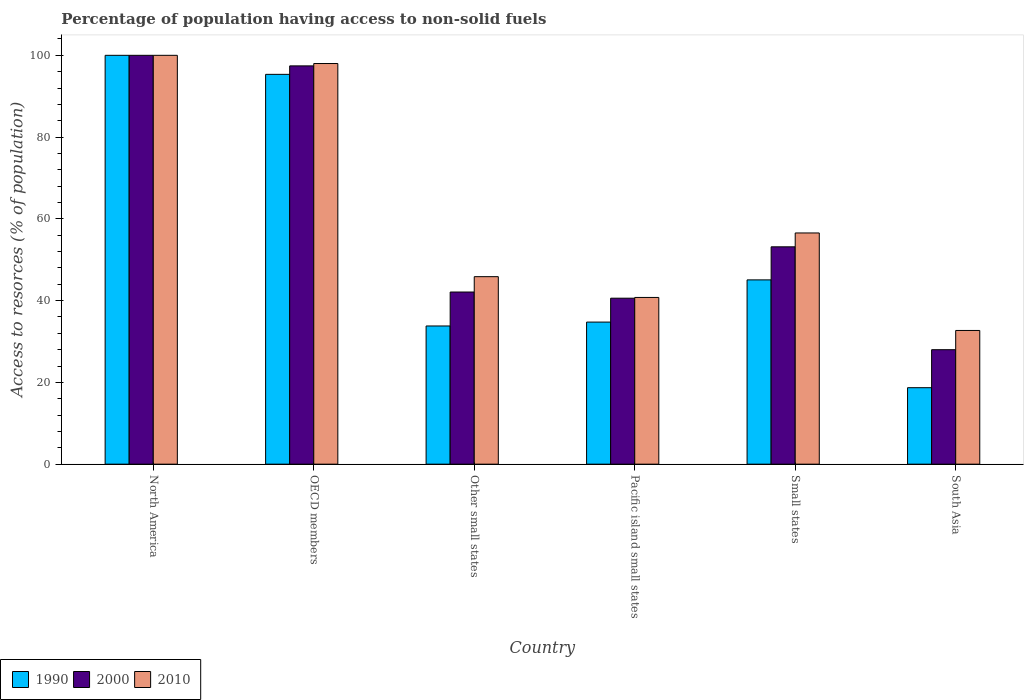Are the number of bars per tick equal to the number of legend labels?
Offer a very short reply. Yes. How many bars are there on the 5th tick from the right?
Your answer should be very brief. 3. What is the label of the 1st group of bars from the left?
Your answer should be compact. North America. What is the percentage of population having access to non-solid fuels in 2000 in OECD members?
Give a very brief answer. 97.42. Across all countries, what is the minimum percentage of population having access to non-solid fuels in 2000?
Keep it short and to the point. 28. In which country was the percentage of population having access to non-solid fuels in 1990 maximum?
Provide a succinct answer. North America. In which country was the percentage of population having access to non-solid fuels in 2000 minimum?
Provide a short and direct response. South Asia. What is the total percentage of population having access to non-solid fuels in 2010 in the graph?
Keep it short and to the point. 373.88. What is the difference between the percentage of population having access to non-solid fuels in 2010 in North America and that in Other small states?
Make the answer very short. 54.14. What is the difference between the percentage of population having access to non-solid fuels in 1990 in North America and the percentage of population having access to non-solid fuels in 2010 in Other small states?
Offer a terse response. 54.14. What is the average percentage of population having access to non-solid fuels in 2000 per country?
Offer a very short reply. 60.21. What is the difference between the percentage of population having access to non-solid fuels of/in 2010 and percentage of population having access to non-solid fuels of/in 2000 in South Asia?
Give a very brief answer. 4.71. In how many countries, is the percentage of population having access to non-solid fuels in 2010 greater than 4 %?
Offer a terse response. 6. What is the ratio of the percentage of population having access to non-solid fuels in 2000 in Other small states to that in South Asia?
Your answer should be very brief. 1.5. Is the percentage of population having access to non-solid fuels in 1990 in OECD members less than that in Small states?
Offer a very short reply. No. What is the difference between the highest and the second highest percentage of population having access to non-solid fuels in 2010?
Make the answer very short. -41.44. What is the difference between the highest and the lowest percentage of population having access to non-solid fuels in 1990?
Make the answer very short. 81.3. In how many countries, is the percentage of population having access to non-solid fuels in 2000 greater than the average percentage of population having access to non-solid fuels in 2000 taken over all countries?
Make the answer very short. 2. Is the sum of the percentage of population having access to non-solid fuels in 1990 in OECD members and Small states greater than the maximum percentage of population having access to non-solid fuels in 2010 across all countries?
Your response must be concise. Yes. What does the 2nd bar from the left in North America represents?
Provide a short and direct response. 2000. What does the 1st bar from the right in Small states represents?
Ensure brevity in your answer.  2010. Are all the bars in the graph horizontal?
Provide a short and direct response. No. Does the graph contain any zero values?
Your answer should be compact. No. What is the title of the graph?
Keep it short and to the point. Percentage of population having access to non-solid fuels. What is the label or title of the Y-axis?
Give a very brief answer. Access to resorces (% of population). What is the Access to resorces (% of population) of 1990 in North America?
Give a very brief answer. 100. What is the Access to resorces (% of population) of 1990 in OECD members?
Offer a terse response. 95.34. What is the Access to resorces (% of population) of 2000 in OECD members?
Offer a very short reply. 97.42. What is the Access to resorces (% of population) of 2010 in OECD members?
Offer a terse response. 97.99. What is the Access to resorces (% of population) of 1990 in Other small states?
Offer a terse response. 33.8. What is the Access to resorces (% of population) in 2000 in Other small states?
Give a very brief answer. 42.11. What is the Access to resorces (% of population) in 2010 in Other small states?
Your response must be concise. 45.86. What is the Access to resorces (% of population) in 1990 in Pacific island small states?
Your answer should be very brief. 34.75. What is the Access to resorces (% of population) in 2000 in Pacific island small states?
Offer a very short reply. 40.6. What is the Access to resorces (% of population) in 2010 in Pacific island small states?
Offer a very short reply. 40.78. What is the Access to resorces (% of population) of 1990 in Small states?
Make the answer very short. 45.07. What is the Access to resorces (% of population) in 2000 in Small states?
Your answer should be very brief. 53.16. What is the Access to resorces (% of population) in 2010 in Small states?
Your answer should be very brief. 56.55. What is the Access to resorces (% of population) in 1990 in South Asia?
Provide a short and direct response. 18.7. What is the Access to resorces (% of population) in 2000 in South Asia?
Your response must be concise. 28. What is the Access to resorces (% of population) of 2010 in South Asia?
Provide a short and direct response. 32.7. Across all countries, what is the maximum Access to resorces (% of population) of 1990?
Provide a short and direct response. 100. Across all countries, what is the maximum Access to resorces (% of population) in 2000?
Provide a short and direct response. 100. Across all countries, what is the maximum Access to resorces (% of population) in 2010?
Make the answer very short. 100. Across all countries, what is the minimum Access to resorces (% of population) of 1990?
Your answer should be very brief. 18.7. Across all countries, what is the minimum Access to resorces (% of population) of 2000?
Offer a terse response. 28. Across all countries, what is the minimum Access to resorces (% of population) in 2010?
Your answer should be very brief. 32.7. What is the total Access to resorces (% of population) in 1990 in the graph?
Keep it short and to the point. 327.67. What is the total Access to resorces (% of population) of 2000 in the graph?
Make the answer very short. 361.28. What is the total Access to resorces (% of population) of 2010 in the graph?
Provide a short and direct response. 373.88. What is the difference between the Access to resorces (% of population) of 1990 in North America and that in OECD members?
Give a very brief answer. 4.66. What is the difference between the Access to resorces (% of population) of 2000 in North America and that in OECD members?
Ensure brevity in your answer.  2.58. What is the difference between the Access to resorces (% of population) of 2010 in North America and that in OECD members?
Your answer should be very brief. 2.01. What is the difference between the Access to resorces (% of population) in 1990 in North America and that in Other small states?
Your answer should be compact. 66.2. What is the difference between the Access to resorces (% of population) in 2000 in North America and that in Other small states?
Ensure brevity in your answer.  57.89. What is the difference between the Access to resorces (% of population) of 2010 in North America and that in Other small states?
Provide a succinct answer. 54.14. What is the difference between the Access to resorces (% of population) in 1990 in North America and that in Pacific island small states?
Offer a terse response. 65.25. What is the difference between the Access to resorces (% of population) in 2000 in North America and that in Pacific island small states?
Your answer should be compact. 59.4. What is the difference between the Access to resorces (% of population) of 2010 in North America and that in Pacific island small states?
Offer a terse response. 59.22. What is the difference between the Access to resorces (% of population) in 1990 in North America and that in Small states?
Provide a short and direct response. 54.93. What is the difference between the Access to resorces (% of population) in 2000 in North America and that in Small states?
Offer a very short reply. 46.84. What is the difference between the Access to resorces (% of population) in 2010 in North America and that in Small states?
Provide a succinct answer. 43.45. What is the difference between the Access to resorces (% of population) of 1990 in North America and that in South Asia?
Provide a short and direct response. 81.3. What is the difference between the Access to resorces (% of population) of 2000 in North America and that in South Asia?
Provide a short and direct response. 72. What is the difference between the Access to resorces (% of population) in 2010 in North America and that in South Asia?
Your response must be concise. 67.3. What is the difference between the Access to resorces (% of population) in 1990 in OECD members and that in Other small states?
Keep it short and to the point. 61.54. What is the difference between the Access to resorces (% of population) of 2000 in OECD members and that in Other small states?
Give a very brief answer. 55.31. What is the difference between the Access to resorces (% of population) in 2010 in OECD members and that in Other small states?
Provide a succinct answer. 52.13. What is the difference between the Access to resorces (% of population) in 1990 in OECD members and that in Pacific island small states?
Your response must be concise. 60.59. What is the difference between the Access to resorces (% of population) in 2000 in OECD members and that in Pacific island small states?
Offer a terse response. 56.82. What is the difference between the Access to resorces (% of population) in 2010 in OECD members and that in Pacific island small states?
Your response must be concise. 57.22. What is the difference between the Access to resorces (% of population) of 1990 in OECD members and that in Small states?
Your answer should be compact. 50.27. What is the difference between the Access to resorces (% of population) of 2000 in OECD members and that in Small states?
Give a very brief answer. 44.26. What is the difference between the Access to resorces (% of population) of 2010 in OECD members and that in Small states?
Your answer should be very brief. 41.44. What is the difference between the Access to resorces (% of population) in 1990 in OECD members and that in South Asia?
Your answer should be very brief. 76.64. What is the difference between the Access to resorces (% of population) in 2000 in OECD members and that in South Asia?
Provide a short and direct response. 69.42. What is the difference between the Access to resorces (% of population) of 2010 in OECD members and that in South Asia?
Your answer should be very brief. 65.29. What is the difference between the Access to resorces (% of population) in 1990 in Other small states and that in Pacific island small states?
Make the answer very short. -0.95. What is the difference between the Access to resorces (% of population) in 2000 in Other small states and that in Pacific island small states?
Provide a succinct answer. 1.51. What is the difference between the Access to resorces (% of population) of 2010 in Other small states and that in Pacific island small states?
Provide a short and direct response. 5.08. What is the difference between the Access to resorces (% of population) in 1990 in Other small states and that in Small states?
Your answer should be compact. -11.27. What is the difference between the Access to resorces (% of population) of 2000 in Other small states and that in Small states?
Make the answer very short. -11.06. What is the difference between the Access to resorces (% of population) of 2010 in Other small states and that in Small states?
Offer a very short reply. -10.69. What is the difference between the Access to resorces (% of population) of 1990 in Other small states and that in South Asia?
Your answer should be compact. 15.1. What is the difference between the Access to resorces (% of population) in 2000 in Other small states and that in South Asia?
Ensure brevity in your answer.  14.11. What is the difference between the Access to resorces (% of population) of 2010 in Other small states and that in South Asia?
Your answer should be compact. 13.16. What is the difference between the Access to resorces (% of population) in 1990 in Pacific island small states and that in Small states?
Offer a very short reply. -10.32. What is the difference between the Access to resorces (% of population) in 2000 in Pacific island small states and that in Small states?
Keep it short and to the point. -12.57. What is the difference between the Access to resorces (% of population) of 2010 in Pacific island small states and that in Small states?
Offer a terse response. -15.77. What is the difference between the Access to resorces (% of population) of 1990 in Pacific island small states and that in South Asia?
Make the answer very short. 16.05. What is the difference between the Access to resorces (% of population) of 2000 in Pacific island small states and that in South Asia?
Ensure brevity in your answer.  12.6. What is the difference between the Access to resorces (% of population) of 2010 in Pacific island small states and that in South Asia?
Keep it short and to the point. 8.07. What is the difference between the Access to resorces (% of population) in 1990 in Small states and that in South Asia?
Offer a very short reply. 26.37. What is the difference between the Access to resorces (% of population) of 2000 in Small states and that in South Asia?
Offer a terse response. 25.16. What is the difference between the Access to resorces (% of population) in 2010 in Small states and that in South Asia?
Give a very brief answer. 23.85. What is the difference between the Access to resorces (% of population) of 1990 in North America and the Access to resorces (% of population) of 2000 in OECD members?
Ensure brevity in your answer.  2.58. What is the difference between the Access to resorces (% of population) in 1990 in North America and the Access to resorces (% of population) in 2010 in OECD members?
Provide a short and direct response. 2.01. What is the difference between the Access to resorces (% of population) in 2000 in North America and the Access to resorces (% of population) in 2010 in OECD members?
Offer a terse response. 2.01. What is the difference between the Access to resorces (% of population) in 1990 in North America and the Access to resorces (% of population) in 2000 in Other small states?
Provide a succinct answer. 57.89. What is the difference between the Access to resorces (% of population) of 1990 in North America and the Access to resorces (% of population) of 2010 in Other small states?
Your answer should be compact. 54.14. What is the difference between the Access to resorces (% of population) in 2000 in North America and the Access to resorces (% of population) in 2010 in Other small states?
Your answer should be very brief. 54.14. What is the difference between the Access to resorces (% of population) of 1990 in North America and the Access to resorces (% of population) of 2000 in Pacific island small states?
Make the answer very short. 59.4. What is the difference between the Access to resorces (% of population) in 1990 in North America and the Access to resorces (% of population) in 2010 in Pacific island small states?
Make the answer very short. 59.22. What is the difference between the Access to resorces (% of population) in 2000 in North America and the Access to resorces (% of population) in 2010 in Pacific island small states?
Keep it short and to the point. 59.22. What is the difference between the Access to resorces (% of population) of 1990 in North America and the Access to resorces (% of population) of 2000 in Small states?
Your answer should be very brief. 46.84. What is the difference between the Access to resorces (% of population) of 1990 in North America and the Access to resorces (% of population) of 2010 in Small states?
Ensure brevity in your answer.  43.45. What is the difference between the Access to resorces (% of population) in 2000 in North America and the Access to resorces (% of population) in 2010 in Small states?
Your response must be concise. 43.45. What is the difference between the Access to resorces (% of population) of 1990 in North America and the Access to resorces (% of population) of 2000 in South Asia?
Your answer should be very brief. 72. What is the difference between the Access to resorces (% of population) in 1990 in North America and the Access to resorces (% of population) in 2010 in South Asia?
Ensure brevity in your answer.  67.3. What is the difference between the Access to resorces (% of population) in 2000 in North America and the Access to resorces (% of population) in 2010 in South Asia?
Your answer should be compact. 67.3. What is the difference between the Access to resorces (% of population) in 1990 in OECD members and the Access to resorces (% of population) in 2000 in Other small states?
Provide a short and direct response. 53.24. What is the difference between the Access to resorces (% of population) of 1990 in OECD members and the Access to resorces (% of population) of 2010 in Other small states?
Your answer should be very brief. 49.48. What is the difference between the Access to resorces (% of population) of 2000 in OECD members and the Access to resorces (% of population) of 2010 in Other small states?
Provide a succinct answer. 51.56. What is the difference between the Access to resorces (% of population) in 1990 in OECD members and the Access to resorces (% of population) in 2000 in Pacific island small states?
Your response must be concise. 54.75. What is the difference between the Access to resorces (% of population) in 1990 in OECD members and the Access to resorces (% of population) in 2010 in Pacific island small states?
Give a very brief answer. 54.57. What is the difference between the Access to resorces (% of population) in 2000 in OECD members and the Access to resorces (% of population) in 2010 in Pacific island small states?
Make the answer very short. 56.64. What is the difference between the Access to resorces (% of population) of 1990 in OECD members and the Access to resorces (% of population) of 2000 in Small states?
Provide a succinct answer. 42.18. What is the difference between the Access to resorces (% of population) in 1990 in OECD members and the Access to resorces (% of population) in 2010 in Small states?
Make the answer very short. 38.79. What is the difference between the Access to resorces (% of population) of 2000 in OECD members and the Access to resorces (% of population) of 2010 in Small states?
Your answer should be compact. 40.87. What is the difference between the Access to resorces (% of population) in 1990 in OECD members and the Access to resorces (% of population) in 2000 in South Asia?
Provide a short and direct response. 67.35. What is the difference between the Access to resorces (% of population) of 1990 in OECD members and the Access to resorces (% of population) of 2010 in South Asia?
Your answer should be compact. 62.64. What is the difference between the Access to resorces (% of population) in 2000 in OECD members and the Access to resorces (% of population) in 2010 in South Asia?
Your answer should be compact. 64.71. What is the difference between the Access to resorces (% of population) in 1990 in Other small states and the Access to resorces (% of population) in 2000 in Pacific island small states?
Offer a very short reply. -6.8. What is the difference between the Access to resorces (% of population) of 1990 in Other small states and the Access to resorces (% of population) of 2010 in Pacific island small states?
Your response must be concise. -6.98. What is the difference between the Access to resorces (% of population) of 2000 in Other small states and the Access to resorces (% of population) of 2010 in Pacific island small states?
Your response must be concise. 1.33. What is the difference between the Access to resorces (% of population) in 1990 in Other small states and the Access to resorces (% of population) in 2000 in Small states?
Your answer should be very brief. -19.36. What is the difference between the Access to resorces (% of population) of 1990 in Other small states and the Access to resorces (% of population) of 2010 in Small states?
Provide a short and direct response. -22.75. What is the difference between the Access to resorces (% of population) of 2000 in Other small states and the Access to resorces (% of population) of 2010 in Small states?
Provide a succinct answer. -14.44. What is the difference between the Access to resorces (% of population) in 1990 in Other small states and the Access to resorces (% of population) in 2000 in South Asia?
Your response must be concise. 5.8. What is the difference between the Access to resorces (% of population) in 1990 in Other small states and the Access to resorces (% of population) in 2010 in South Asia?
Provide a succinct answer. 1.1. What is the difference between the Access to resorces (% of population) in 2000 in Other small states and the Access to resorces (% of population) in 2010 in South Asia?
Your response must be concise. 9.4. What is the difference between the Access to resorces (% of population) of 1990 in Pacific island small states and the Access to resorces (% of population) of 2000 in Small states?
Ensure brevity in your answer.  -18.41. What is the difference between the Access to resorces (% of population) in 1990 in Pacific island small states and the Access to resorces (% of population) in 2010 in Small states?
Make the answer very short. -21.8. What is the difference between the Access to resorces (% of population) of 2000 in Pacific island small states and the Access to resorces (% of population) of 2010 in Small states?
Your answer should be compact. -15.95. What is the difference between the Access to resorces (% of population) in 1990 in Pacific island small states and the Access to resorces (% of population) in 2000 in South Asia?
Offer a very short reply. 6.75. What is the difference between the Access to resorces (% of population) in 1990 in Pacific island small states and the Access to resorces (% of population) in 2010 in South Asia?
Provide a short and direct response. 2.05. What is the difference between the Access to resorces (% of population) in 2000 in Pacific island small states and the Access to resorces (% of population) in 2010 in South Asia?
Make the answer very short. 7.89. What is the difference between the Access to resorces (% of population) in 1990 in Small states and the Access to resorces (% of population) in 2000 in South Asia?
Ensure brevity in your answer.  17.08. What is the difference between the Access to resorces (% of population) in 1990 in Small states and the Access to resorces (% of population) in 2010 in South Asia?
Provide a succinct answer. 12.37. What is the difference between the Access to resorces (% of population) in 2000 in Small states and the Access to resorces (% of population) in 2010 in South Asia?
Keep it short and to the point. 20.46. What is the average Access to resorces (% of population) in 1990 per country?
Give a very brief answer. 54.61. What is the average Access to resorces (% of population) in 2000 per country?
Your answer should be compact. 60.21. What is the average Access to resorces (% of population) of 2010 per country?
Your response must be concise. 62.31. What is the difference between the Access to resorces (% of population) in 1990 and Access to resorces (% of population) in 2000 in North America?
Ensure brevity in your answer.  0. What is the difference between the Access to resorces (% of population) of 1990 and Access to resorces (% of population) of 2000 in OECD members?
Give a very brief answer. -2.07. What is the difference between the Access to resorces (% of population) of 1990 and Access to resorces (% of population) of 2010 in OECD members?
Give a very brief answer. -2.65. What is the difference between the Access to resorces (% of population) of 2000 and Access to resorces (% of population) of 2010 in OECD members?
Provide a succinct answer. -0.57. What is the difference between the Access to resorces (% of population) in 1990 and Access to resorces (% of population) in 2000 in Other small states?
Your response must be concise. -8.31. What is the difference between the Access to resorces (% of population) of 1990 and Access to resorces (% of population) of 2010 in Other small states?
Provide a succinct answer. -12.06. What is the difference between the Access to resorces (% of population) of 2000 and Access to resorces (% of population) of 2010 in Other small states?
Your answer should be very brief. -3.75. What is the difference between the Access to resorces (% of population) of 1990 and Access to resorces (% of population) of 2000 in Pacific island small states?
Ensure brevity in your answer.  -5.85. What is the difference between the Access to resorces (% of population) in 1990 and Access to resorces (% of population) in 2010 in Pacific island small states?
Offer a very short reply. -6.03. What is the difference between the Access to resorces (% of population) in 2000 and Access to resorces (% of population) in 2010 in Pacific island small states?
Your answer should be compact. -0.18. What is the difference between the Access to resorces (% of population) of 1990 and Access to resorces (% of population) of 2000 in Small states?
Keep it short and to the point. -8.09. What is the difference between the Access to resorces (% of population) of 1990 and Access to resorces (% of population) of 2010 in Small states?
Offer a terse response. -11.48. What is the difference between the Access to resorces (% of population) in 2000 and Access to resorces (% of population) in 2010 in Small states?
Keep it short and to the point. -3.39. What is the difference between the Access to resorces (% of population) in 1990 and Access to resorces (% of population) in 2000 in South Asia?
Your response must be concise. -9.3. What is the difference between the Access to resorces (% of population) of 1990 and Access to resorces (% of population) of 2010 in South Asia?
Offer a very short reply. -14. What is the difference between the Access to resorces (% of population) in 2000 and Access to resorces (% of population) in 2010 in South Asia?
Your response must be concise. -4.71. What is the ratio of the Access to resorces (% of population) of 1990 in North America to that in OECD members?
Your response must be concise. 1.05. What is the ratio of the Access to resorces (% of population) in 2000 in North America to that in OECD members?
Your response must be concise. 1.03. What is the ratio of the Access to resorces (% of population) of 2010 in North America to that in OECD members?
Provide a succinct answer. 1.02. What is the ratio of the Access to resorces (% of population) in 1990 in North America to that in Other small states?
Give a very brief answer. 2.96. What is the ratio of the Access to resorces (% of population) of 2000 in North America to that in Other small states?
Your answer should be compact. 2.38. What is the ratio of the Access to resorces (% of population) of 2010 in North America to that in Other small states?
Your answer should be very brief. 2.18. What is the ratio of the Access to resorces (% of population) in 1990 in North America to that in Pacific island small states?
Offer a very short reply. 2.88. What is the ratio of the Access to resorces (% of population) in 2000 in North America to that in Pacific island small states?
Provide a short and direct response. 2.46. What is the ratio of the Access to resorces (% of population) of 2010 in North America to that in Pacific island small states?
Your response must be concise. 2.45. What is the ratio of the Access to resorces (% of population) in 1990 in North America to that in Small states?
Ensure brevity in your answer.  2.22. What is the ratio of the Access to resorces (% of population) in 2000 in North America to that in Small states?
Offer a terse response. 1.88. What is the ratio of the Access to resorces (% of population) of 2010 in North America to that in Small states?
Your response must be concise. 1.77. What is the ratio of the Access to resorces (% of population) in 1990 in North America to that in South Asia?
Provide a succinct answer. 5.35. What is the ratio of the Access to resorces (% of population) of 2000 in North America to that in South Asia?
Make the answer very short. 3.57. What is the ratio of the Access to resorces (% of population) of 2010 in North America to that in South Asia?
Offer a very short reply. 3.06. What is the ratio of the Access to resorces (% of population) in 1990 in OECD members to that in Other small states?
Offer a very short reply. 2.82. What is the ratio of the Access to resorces (% of population) in 2000 in OECD members to that in Other small states?
Ensure brevity in your answer.  2.31. What is the ratio of the Access to resorces (% of population) of 2010 in OECD members to that in Other small states?
Make the answer very short. 2.14. What is the ratio of the Access to resorces (% of population) of 1990 in OECD members to that in Pacific island small states?
Your answer should be very brief. 2.74. What is the ratio of the Access to resorces (% of population) in 2000 in OECD members to that in Pacific island small states?
Your response must be concise. 2.4. What is the ratio of the Access to resorces (% of population) of 2010 in OECD members to that in Pacific island small states?
Give a very brief answer. 2.4. What is the ratio of the Access to resorces (% of population) of 1990 in OECD members to that in Small states?
Make the answer very short. 2.12. What is the ratio of the Access to resorces (% of population) in 2000 in OECD members to that in Small states?
Offer a very short reply. 1.83. What is the ratio of the Access to resorces (% of population) of 2010 in OECD members to that in Small states?
Ensure brevity in your answer.  1.73. What is the ratio of the Access to resorces (% of population) of 1990 in OECD members to that in South Asia?
Your answer should be compact. 5.1. What is the ratio of the Access to resorces (% of population) of 2000 in OECD members to that in South Asia?
Your answer should be compact. 3.48. What is the ratio of the Access to resorces (% of population) in 2010 in OECD members to that in South Asia?
Give a very brief answer. 3. What is the ratio of the Access to resorces (% of population) of 1990 in Other small states to that in Pacific island small states?
Give a very brief answer. 0.97. What is the ratio of the Access to resorces (% of population) of 2000 in Other small states to that in Pacific island small states?
Provide a succinct answer. 1.04. What is the ratio of the Access to resorces (% of population) in 2010 in Other small states to that in Pacific island small states?
Give a very brief answer. 1.12. What is the ratio of the Access to resorces (% of population) of 1990 in Other small states to that in Small states?
Offer a terse response. 0.75. What is the ratio of the Access to resorces (% of population) in 2000 in Other small states to that in Small states?
Your answer should be very brief. 0.79. What is the ratio of the Access to resorces (% of population) of 2010 in Other small states to that in Small states?
Keep it short and to the point. 0.81. What is the ratio of the Access to resorces (% of population) of 1990 in Other small states to that in South Asia?
Ensure brevity in your answer.  1.81. What is the ratio of the Access to resorces (% of population) of 2000 in Other small states to that in South Asia?
Give a very brief answer. 1.5. What is the ratio of the Access to resorces (% of population) in 2010 in Other small states to that in South Asia?
Give a very brief answer. 1.4. What is the ratio of the Access to resorces (% of population) in 1990 in Pacific island small states to that in Small states?
Your response must be concise. 0.77. What is the ratio of the Access to resorces (% of population) in 2000 in Pacific island small states to that in Small states?
Your answer should be very brief. 0.76. What is the ratio of the Access to resorces (% of population) of 2010 in Pacific island small states to that in Small states?
Make the answer very short. 0.72. What is the ratio of the Access to resorces (% of population) of 1990 in Pacific island small states to that in South Asia?
Make the answer very short. 1.86. What is the ratio of the Access to resorces (% of population) of 2000 in Pacific island small states to that in South Asia?
Make the answer very short. 1.45. What is the ratio of the Access to resorces (% of population) of 2010 in Pacific island small states to that in South Asia?
Provide a succinct answer. 1.25. What is the ratio of the Access to resorces (% of population) in 1990 in Small states to that in South Asia?
Your answer should be compact. 2.41. What is the ratio of the Access to resorces (% of population) of 2000 in Small states to that in South Asia?
Give a very brief answer. 1.9. What is the ratio of the Access to resorces (% of population) of 2010 in Small states to that in South Asia?
Offer a terse response. 1.73. What is the difference between the highest and the second highest Access to resorces (% of population) in 1990?
Your response must be concise. 4.66. What is the difference between the highest and the second highest Access to resorces (% of population) in 2000?
Keep it short and to the point. 2.58. What is the difference between the highest and the second highest Access to resorces (% of population) in 2010?
Ensure brevity in your answer.  2.01. What is the difference between the highest and the lowest Access to resorces (% of population) in 1990?
Keep it short and to the point. 81.3. What is the difference between the highest and the lowest Access to resorces (% of population) in 2000?
Your response must be concise. 72. What is the difference between the highest and the lowest Access to resorces (% of population) of 2010?
Make the answer very short. 67.3. 